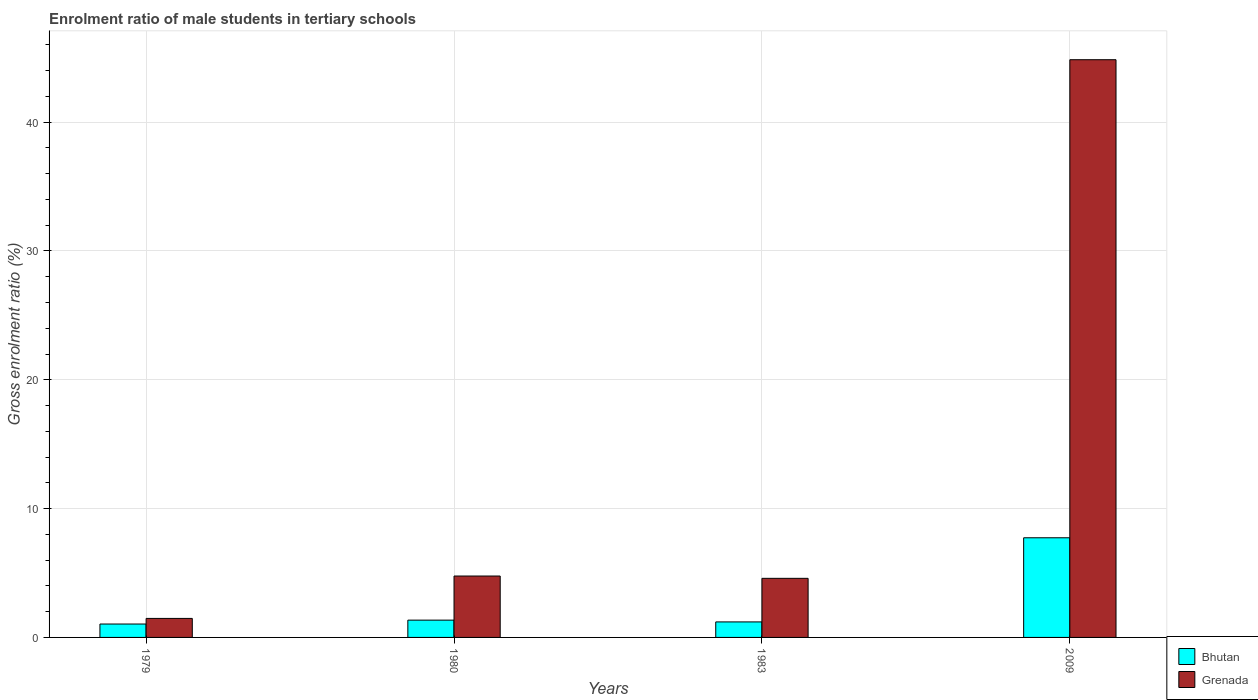Are the number of bars per tick equal to the number of legend labels?
Give a very brief answer. Yes. How many bars are there on the 3rd tick from the left?
Your answer should be very brief. 2. What is the enrolment ratio of male students in tertiary schools in Grenada in 1980?
Make the answer very short. 4.77. Across all years, what is the maximum enrolment ratio of male students in tertiary schools in Bhutan?
Give a very brief answer. 7.74. Across all years, what is the minimum enrolment ratio of male students in tertiary schools in Grenada?
Give a very brief answer. 1.48. In which year was the enrolment ratio of male students in tertiary schools in Grenada maximum?
Offer a very short reply. 2009. In which year was the enrolment ratio of male students in tertiary schools in Grenada minimum?
Your response must be concise. 1979. What is the total enrolment ratio of male students in tertiary schools in Bhutan in the graph?
Your response must be concise. 11.32. What is the difference between the enrolment ratio of male students in tertiary schools in Bhutan in 1979 and that in 1980?
Provide a succinct answer. -0.3. What is the difference between the enrolment ratio of male students in tertiary schools in Bhutan in 1983 and the enrolment ratio of male students in tertiary schools in Grenada in 1979?
Offer a very short reply. -0.27. What is the average enrolment ratio of male students in tertiary schools in Bhutan per year?
Offer a very short reply. 2.83. In the year 1983, what is the difference between the enrolment ratio of male students in tertiary schools in Bhutan and enrolment ratio of male students in tertiary schools in Grenada?
Make the answer very short. -3.38. In how many years, is the enrolment ratio of male students in tertiary schools in Grenada greater than 26 %?
Your answer should be very brief. 1. What is the ratio of the enrolment ratio of male students in tertiary schools in Bhutan in 1983 to that in 2009?
Keep it short and to the point. 0.16. Is the enrolment ratio of male students in tertiary schools in Grenada in 1979 less than that in 1983?
Provide a short and direct response. Yes. What is the difference between the highest and the second highest enrolment ratio of male students in tertiary schools in Grenada?
Make the answer very short. 40.08. What is the difference between the highest and the lowest enrolment ratio of male students in tertiary schools in Bhutan?
Provide a short and direct response. 6.69. What does the 1st bar from the left in 2009 represents?
Make the answer very short. Bhutan. What does the 1st bar from the right in 1980 represents?
Offer a very short reply. Grenada. How many bars are there?
Ensure brevity in your answer.  8. Are all the bars in the graph horizontal?
Keep it short and to the point. No. What is the difference between two consecutive major ticks on the Y-axis?
Make the answer very short. 10. Are the values on the major ticks of Y-axis written in scientific E-notation?
Make the answer very short. No. Does the graph contain any zero values?
Provide a short and direct response. No. Where does the legend appear in the graph?
Offer a terse response. Bottom right. How many legend labels are there?
Your answer should be compact. 2. What is the title of the graph?
Ensure brevity in your answer.  Enrolment ratio of male students in tertiary schools. What is the label or title of the X-axis?
Your answer should be very brief. Years. What is the label or title of the Y-axis?
Make the answer very short. Gross enrolment ratio (%). What is the Gross enrolment ratio (%) in Bhutan in 1979?
Offer a very short reply. 1.04. What is the Gross enrolment ratio (%) of Grenada in 1979?
Your response must be concise. 1.48. What is the Gross enrolment ratio (%) of Bhutan in 1980?
Offer a terse response. 1.34. What is the Gross enrolment ratio (%) of Grenada in 1980?
Your response must be concise. 4.77. What is the Gross enrolment ratio (%) of Bhutan in 1983?
Make the answer very short. 1.2. What is the Gross enrolment ratio (%) in Grenada in 1983?
Provide a succinct answer. 4.59. What is the Gross enrolment ratio (%) in Bhutan in 2009?
Your answer should be compact. 7.74. What is the Gross enrolment ratio (%) in Grenada in 2009?
Offer a terse response. 44.85. Across all years, what is the maximum Gross enrolment ratio (%) in Bhutan?
Make the answer very short. 7.74. Across all years, what is the maximum Gross enrolment ratio (%) of Grenada?
Offer a very short reply. 44.85. Across all years, what is the minimum Gross enrolment ratio (%) of Bhutan?
Your answer should be very brief. 1.04. Across all years, what is the minimum Gross enrolment ratio (%) in Grenada?
Offer a terse response. 1.48. What is the total Gross enrolment ratio (%) in Bhutan in the graph?
Ensure brevity in your answer.  11.32. What is the total Gross enrolment ratio (%) in Grenada in the graph?
Give a very brief answer. 55.68. What is the difference between the Gross enrolment ratio (%) of Bhutan in 1979 and that in 1980?
Provide a succinct answer. -0.3. What is the difference between the Gross enrolment ratio (%) in Grenada in 1979 and that in 1980?
Offer a very short reply. -3.29. What is the difference between the Gross enrolment ratio (%) in Bhutan in 1979 and that in 1983?
Make the answer very short. -0.16. What is the difference between the Gross enrolment ratio (%) of Grenada in 1979 and that in 1983?
Offer a terse response. -3.11. What is the difference between the Gross enrolment ratio (%) of Bhutan in 1979 and that in 2009?
Make the answer very short. -6.69. What is the difference between the Gross enrolment ratio (%) in Grenada in 1979 and that in 2009?
Offer a terse response. -43.37. What is the difference between the Gross enrolment ratio (%) in Bhutan in 1980 and that in 1983?
Provide a succinct answer. 0.14. What is the difference between the Gross enrolment ratio (%) of Grenada in 1980 and that in 1983?
Provide a succinct answer. 0.18. What is the difference between the Gross enrolment ratio (%) in Bhutan in 1980 and that in 2009?
Keep it short and to the point. -6.39. What is the difference between the Gross enrolment ratio (%) in Grenada in 1980 and that in 2009?
Your response must be concise. -40.08. What is the difference between the Gross enrolment ratio (%) of Bhutan in 1983 and that in 2009?
Provide a short and direct response. -6.53. What is the difference between the Gross enrolment ratio (%) of Grenada in 1983 and that in 2009?
Your answer should be compact. -40.26. What is the difference between the Gross enrolment ratio (%) in Bhutan in 1979 and the Gross enrolment ratio (%) in Grenada in 1980?
Make the answer very short. -3.73. What is the difference between the Gross enrolment ratio (%) of Bhutan in 1979 and the Gross enrolment ratio (%) of Grenada in 1983?
Your answer should be very brief. -3.55. What is the difference between the Gross enrolment ratio (%) in Bhutan in 1979 and the Gross enrolment ratio (%) in Grenada in 2009?
Your answer should be very brief. -43.8. What is the difference between the Gross enrolment ratio (%) in Bhutan in 1980 and the Gross enrolment ratio (%) in Grenada in 1983?
Your response must be concise. -3.24. What is the difference between the Gross enrolment ratio (%) in Bhutan in 1980 and the Gross enrolment ratio (%) in Grenada in 2009?
Provide a succinct answer. -43.5. What is the difference between the Gross enrolment ratio (%) in Bhutan in 1983 and the Gross enrolment ratio (%) in Grenada in 2009?
Your answer should be compact. -43.64. What is the average Gross enrolment ratio (%) of Bhutan per year?
Your answer should be very brief. 2.83. What is the average Gross enrolment ratio (%) of Grenada per year?
Keep it short and to the point. 13.92. In the year 1979, what is the difference between the Gross enrolment ratio (%) of Bhutan and Gross enrolment ratio (%) of Grenada?
Your answer should be very brief. -0.44. In the year 1980, what is the difference between the Gross enrolment ratio (%) in Bhutan and Gross enrolment ratio (%) in Grenada?
Your answer should be very brief. -3.42. In the year 1983, what is the difference between the Gross enrolment ratio (%) of Bhutan and Gross enrolment ratio (%) of Grenada?
Your answer should be very brief. -3.38. In the year 2009, what is the difference between the Gross enrolment ratio (%) in Bhutan and Gross enrolment ratio (%) in Grenada?
Your response must be concise. -37.11. What is the ratio of the Gross enrolment ratio (%) in Bhutan in 1979 to that in 1980?
Make the answer very short. 0.77. What is the ratio of the Gross enrolment ratio (%) in Grenada in 1979 to that in 1980?
Your answer should be compact. 0.31. What is the ratio of the Gross enrolment ratio (%) of Bhutan in 1979 to that in 1983?
Offer a terse response. 0.86. What is the ratio of the Gross enrolment ratio (%) in Grenada in 1979 to that in 1983?
Keep it short and to the point. 0.32. What is the ratio of the Gross enrolment ratio (%) of Bhutan in 1979 to that in 2009?
Offer a very short reply. 0.13. What is the ratio of the Gross enrolment ratio (%) of Grenada in 1979 to that in 2009?
Keep it short and to the point. 0.03. What is the ratio of the Gross enrolment ratio (%) in Bhutan in 1980 to that in 1983?
Keep it short and to the point. 1.11. What is the ratio of the Gross enrolment ratio (%) in Grenada in 1980 to that in 1983?
Ensure brevity in your answer.  1.04. What is the ratio of the Gross enrolment ratio (%) in Bhutan in 1980 to that in 2009?
Keep it short and to the point. 0.17. What is the ratio of the Gross enrolment ratio (%) of Grenada in 1980 to that in 2009?
Your answer should be very brief. 0.11. What is the ratio of the Gross enrolment ratio (%) in Bhutan in 1983 to that in 2009?
Ensure brevity in your answer.  0.16. What is the ratio of the Gross enrolment ratio (%) of Grenada in 1983 to that in 2009?
Your answer should be compact. 0.1. What is the difference between the highest and the second highest Gross enrolment ratio (%) in Bhutan?
Your answer should be compact. 6.39. What is the difference between the highest and the second highest Gross enrolment ratio (%) in Grenada?
Provide a succinct answer. 40.08. What is the difference between the highest and the lowest Gross enrolment ratio (%) in Bhutan?
Ensure brevity in your answer.  6.69. What is the difference between the highest and the lowest Gross enrolment ratio (%) in Grenada?
Offer a terse response. 43.37. 